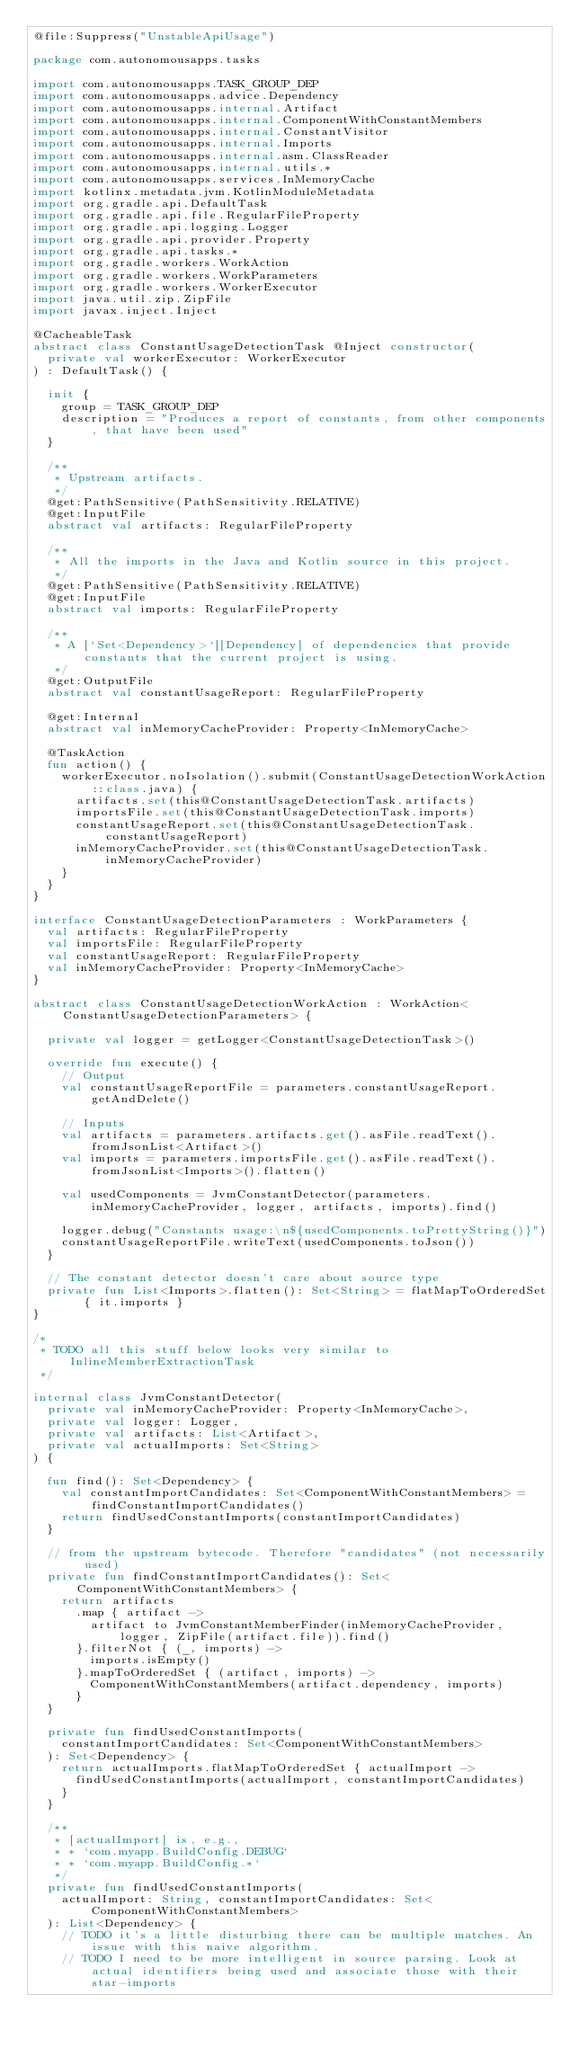Convert code to text. <code><loc_0><loc_0><loc_500><loc_500><_Kotlin_>@file:Suppress("UnstableApiUsage")

package com.autonomousapps.tasks

import com.autonomousapps.TASK_GROUP_DEP
import com.autonomousapps.advice.Dependency
import com.autonomousapps.internal.Artifact
import com.autonomousapps.internal.ComponentWithConstantMembers
import com.autonomousapps.internal.ConstantVisitor
import com.autonomousapps.internal.Imports
import com.autonomousapps.internal.asm.ClassReader
import com.autonomousapps.internal.utils.*
import com.autonomousapps.services.InMemoryCache
import kotlinx.metadata.jvm.KotlinModuleMetadata
import org.gradle.api.DefaultTask
import org.gradle.api.file.RegularFileProperty
import org.gradle.api.logging.Logger
import org.gradle.api.provider.Property
import org.gradle.api.tasks.*
import org.gradle.workers.WorkAction
import org.gradle.workers.WorkParameters
import org.gradle.workers.WorkerExecutor
import java.util.zip.ZipFile
import javax.inject.Inject

@CacheableTask
abstract class ConstantUsageDetectionTask @Inject constructor(
  private val workerExecutor: WorkerExecutor
) : DefaultTask() {

  init {
    group = TASK_GROUP_DEP
    description = "Produces a report of constants, from other components, that have been used"
  }

  /**
   * Upstream artifacts.
   */
  @get:PathSensitive(PathSensitivity.RELATIVE)
  @get:InputFile
  abstract val artifacts: RegularFileProperty

  /**
   * All the imports in the Java and Kotlin source in this project.
   */
  @get:PathSensitive(PathSensitivity.RELATIVE)
  @get:InputFile
  abstract val imports: RegularFileProperty

  /**
   * A [`Set<Dependency>`][Dependency] of dependencies that provide constants that the current project is using.
   */
  @get:OutputFile
  abstract val constantUsageReport: RegularFileProperty

  @get:Internal
  abstract val inMemoryCacheProvider: Property<InMemoryCache>

  @TaskAction
  fun action() {
    workerExecutor.noIsolation().submit(ConstantUsageDetectionWorkAction::class.java) {
      artifacts.set(this@ConstantUsageDetectionTask.artifacts)
      importsFile.set(this@ConstantUsageDetectionTask.imports)
      constantUsageReport.set(this@ConstantUsageDetectionTask.constantUsageReport)
      inMemoryCacheProvider.set(this@ConstantUsageDetectionTask.inMemoryCacheProvider)
    }
  }
}

interface ConstantUsageDetectionParameters : WorkParameters {
  val artifacts: RegularFileProperty
  val importsFile: RegularFileProperty
  val constantUsageReport: RegularFileProperty
  val inMemoryCacheProvider: Property<InMemoryCache>
}

abstract class ConstantUsageDetectionWorkAction : WorkAction<ConstantUsageDetectionParameters> {

  private val logger = getLogger<ConstantUsageDetectionTask>()

  override fun execute() {
    // Output
    val constantUsageReportFile = parameters.constantUsageReport.getAndDelete()

    // Inputs
    val artifacts = parameters.artifacts.get().asFile.readText().fromJsonList<Artifact>()
    val imports = parameters.importsFile.get().asFile.readText().fromJsonList<Imports>().flatten()

    val usedComponents = JvmConstantDetector(parameters.inMemoryCacheProvider, logger, artifacts, imports).find()

    logger.debug("Constants usage:\n${usedComponents.toPrettyString()}")
    constantUsageReportFile.writeText(usedComponents.toJson())
  }

  // The constant detector doesn't care about source type
  private fun List<Imports>.flatten(): Set<String> = flatMapToOrderedSet { it.imports }
}

/*
 * TODO all this stuff below looks very similar to InlineMemberExtractionTask
 */

internal class JvmConstantDetector(
  private val inMemoryCacheProvider: Property<InMemoryCache>,
  private val logger: Logger,
  private val artifacts: List<Artifact>,
  private val actualImports: Set<String>
) {

  fun find(): Set<Dependency> {
    val constantImportCandidates: Set<ComponentWithConstantMembers> = findConstantImportCandidates()
    return findUsedConstantImports(constantImportCandidates)
  }

  // from the upstream bytecode. Therefore "candidates" (not necessarily used)
  private fun findConstantImportCandidates(): Set<ComponentWithConstantMembers> {
    return artifacts
      .map { artifact ->
        artifact to JvmConstantMemberFinder(inMemoryCacheProvider, logger, ZipFile(artifact.file)).find()
      }.filterNot { (_, imports) ->
        imports.isEmpty()
      }.mapToOrderedSet { (artifact, imports) ->
        ComponentWithConstantMembers(artifact.dependency, imports)
      }
  }

  private fun findUsedConstantImports(
    constantImportCandidates: Set<ComponentWithConstantMembers>
  ): Set<Dependency> {
    return actualImports.flatMapToOrderedSet { actualImport ->
      findUsedConstantImports(actualImport, constantImportCandidates)
    }
  }

  /**
   * [actualImport] is, e.g.,
   * * `com.myapp.BuildConfig.DEBUG`
   * * `com.myapp.BuildConfig.*`
   */
  private fun findUsedConstantImports(
    actualImport: String, constantImportCandidates: Set<ComponentWithConstantMembers>
  ): List<Dependency> {
    // TODO it's a little disturbing there can be multiple matches. An issue with this naive algorithm.
    // TODO I need to be more intelligent in source parsing. Look at actual identifiers being used and associate those with their star-imports</code> 